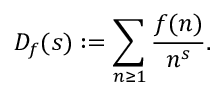Convert formula to latex. <formula><loc_0><loc_0><loc_500><loc_500>D _ { f } ( s ) \colon = \sum _ { n \geq 1 } { \frac { f ( n ) } { n ^ { s } } } .</formula> 